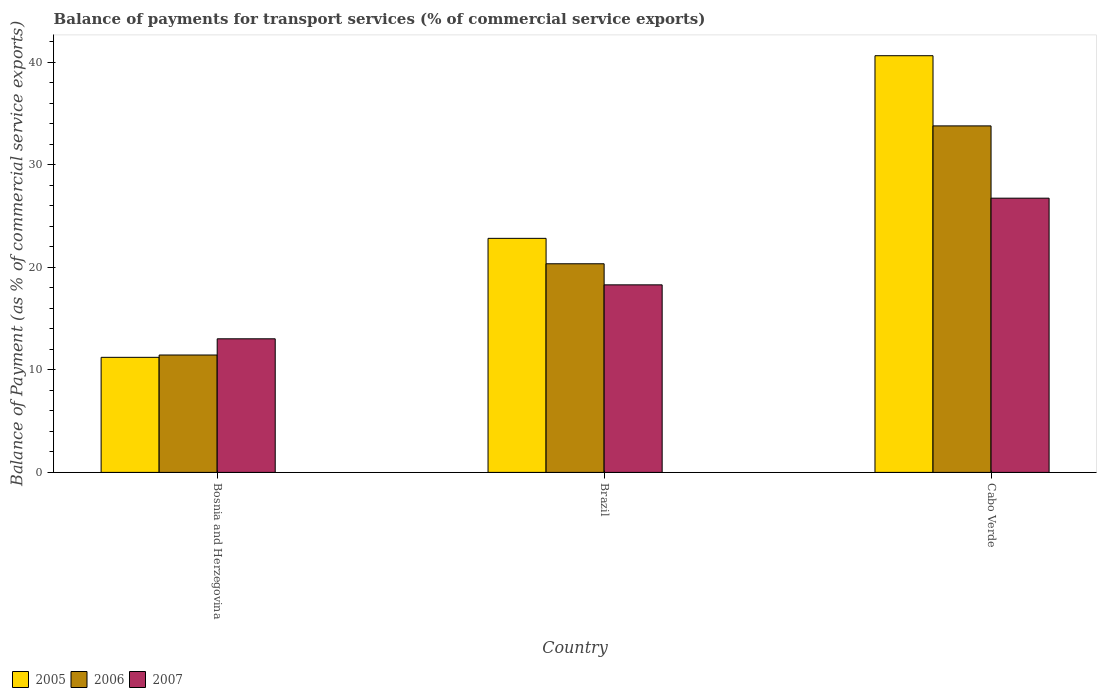How many different coloured bars are there?
Your answer should be compact. 3. Are the number of bars on each tick of the X-axis equal?
Provide a succinct answer. Yes. How many bars are there on the 1st tick from the left?
Provide a succinct answer. 3. How many bars are there on the 3rd tick from the right?
Make the answer very short. 3. What is the label of the 3rd group of bars from the left?
Make the answer very short. Cabo Verde. What is the balance of payments for transport services in 2007 in Cabo Verde?
Your answer should be very brief. 26.75. Across all countries, what is the maximum balance of payments for transport services in 2007?
Provide a succinct answer. 26.75. Across all countries, what is the minimum balance of payments for transport services in 2006?
Make the answer very short. 11.45. In which country was the balance of payments for transport services in 2006 maximum?
Provide a succinct answer. Cabo Verde. In which country was the balance of payments for transport services in 2005 minimum?
Provide a short and direct response. Bosnia and Herzegovina. What is the total balance of payments for transport services in 2005 in the graph?
Offer a very short reply. 74.69. What is the difference between the balance of payments for transport services in 2005 in Brazil and that in Cabo Verde?
Your answer should be compact. -17.81. What is the difference between the balance of payments for transport services in 2005 in Cabo Verde and the balance of payments for transport services in 2006 in Brazil?
Provide a succinct answer. 20.29. What is the average balance of payments for transport services in 2005 per country?
Give a very brief answer. 24.9. What is the difference between the balance of payments for transport services of/in 2006 and balance of payments for transport services of/in 2005 in Bosnia and Herzegovina?
Keep it short and to the point. 0.23. What is the ratio of the balance of payments for transport services in 2006 in Bosnia and Herzegovina to that in Cabo Verde?
Give a very brief answer. 0.34. Is the balance of payments for transport services in 2005 in Bosnia and Herzegovina less than that in Cabo Verde?
Your answer should be compact. Yes. Is the difference between the balance of payments for transport services in 2006 in Bosnia and Herzegovina and Cabo Verde greater than the difference between the balance of payments for transport services in 2005 in Bosnia and Herzegovina and Cabo Verde?
Offer a very short reply. Yes. What is the difference between the highest and the second highest balance of payments for transport services in 2005?
Your response must be concise. 29.42. What is the difference between the highest and the lowest balance of payments for transport services in 2005?
Provide a succinct answer. 29.42. In how many countries, is the balance of payments for transport services in 2007 greater than the average balance of payments for transport services in 2007 taken over all countries?
Provide a short and direct response. 1. Is the sum of the balance of payments for transport services in 2007 in Bosnia and Herzegovina and Brazil greater than the maximum balance of payments for transport services in 2005 across all countries?
Keep it short and to the point. No. What does the 1st bar from the left in Brazil represents?
Offer a very short reply. 2005. What does the 3rd bar from the right in Cabo Verde represents?
Ensure brevity in your answer.  2005. Is it the case that in every country, the sum of the balance of payments for transport services in 2006 and balance of payments for transport services in 2005 is greater than the balance of payments for transport services in 2007?
Offer a terse response. Yes. How many bars are there?
Your answer should be compact. 9. Are all the bars in the graph horizontal?
Provide a short and direct response. No. What is the difference between two consecutive major ticks on the Y-axis?
Make the answer very short. 10. Does the graph contain any zero values?
Your answer should be compact. No. How are the legend labels stacked?
Keep it short and to the point. Horizontal. What is the title of the graph?
Offer a very short reply. Balance of payments for transport services (% of commercial service exports). What is the label or title of the Y-axis?
Provide a short and direct response. Balance of Payment (as % of commercial service exports). What is the Balance of Payment (as % of commercial service exports) of 2005 in Bosnia and Herzegovina?
Offer a terse response. 11.22. What is the Balance of Payment (as % of commercial service exports) in 2006 in Bosnia and Herzegovina?
Ensure brevity in your answer.  11.45. What is the Balance of Payment (as % of commercial service exports) in 2007 in Bosnia and Herzegovina?
Keep it short and to the point. 13.03. What is the Balance of Payment (as % of commercial service exports) in 2005 in Brazil?
Provide a succinct answer. 22.83. What is the Balance of Payment (as % of commercial service exports) of 2006 in Brazil?
Offer a terse response. 20.35. What is the Balance of Payment (as % of commercial service exports) of 2007 in Brazil?
Your answer should be compact. 18.29. What is the Balance of Payment (as % of commercial service exports) in 2005 in Cabo Verde?
Provide a succinct answer. 40.64. What is the Balance of Payment (as % of commercial service exports) of 2006 in Cabo Verde?
Your answer should be compact. 33.79. What is the Balance of Payment (as % of commercial service exports) in 2007 in Cabo Verde?
Your answer should be compact. 26.75. Across all countries, what is the maximum Balance of Payment (as % of commercial service exports) in 2005?
Ensure brevity in your answer.  40.64. Across all countries, what is the maximum Balance of Payment (as % of commercial service exports) of 2006?
Provide a short and direct response. 33.79. Across all countries, what is the maximum Balance of Payment (as % of commercial service exports) in 2007?
Give a very brief answer. 26.75. Across all countries, what is the minimum Balance of Payment (as % of commercial service exports) in 2005?
Your response must be concise. 11.22. Across all countries, what is the minimum Balance of Payment (as % of commercial service exports) in 2006?
Provide a succinct answer. 11.45. Across all countries, what is the minimum Balance of Payment (as % of commercial service exports) of 2007?
Ensure brevity in your answer.  13.03. What is the total Balance of Payment (as % of commercial service exports) in 2005 in the graph?
Your answer should be compact. 74.69. What is the total Balance of Payment (as % of commercial service exports) in 2006 in the graph?
Your answer should be very brief. 65.59. What is the total Balance of Payment (as % of commercial service exports) of 2007 in the graph?
Offer a very short reply. 58.07. What is the difference between the Balance of Payment (as % of commercial service exports) in 2005 in Bosnia and Herzegovina and that in Brazil?
Your answer should be compact. -11.6. What is the difference between the Balance of Payment (as % of commercial service exports) of 2006 in Bosnia and Herzegovina and that in Brazil?
Give a very brief answer. -8.9. What is the difference between the Balance of Payment (as % of commercial service exports) in 2007 in Bosnia and Herzegovina and that in Brazil?
Your response must be concise. -5.26. What is the difference between the Balance of Payment (as % of commercial service exports) of 2005 in Bosnia and Herzegovina and that in Cabo Verde?
Your answer should be very brief. -29.42. What is the difference between the Balance of Payment (as % of commercial service exports) of 2006 in Bosnia and Herzegovina and that in Cabo Verde?
Make the answer very short. -22.35. What is the difference between the Balance of Payment (as % of commercial service exports) in 2007 in Bosnia and Herzegovina and that in Cabo Verde?
Ensure brevity in your answer.  -13.72. What is the difference between the Balance of Payment (as % of commercial service exports) of 2005 in Brazil and that in Cabo Verde?
Provide a short and direct response. -17.81. What is the difference between the Balance of Payment (as % of commercial service exports) of 2006 in Brazil and that in Cabo Verde?
Provide a short and direct response. -13.45. What is the difference between the Balance of Payment (as % of commercial service exports) in 2007 in Brazil and that in Cabo Verde?
Ensure brevity in your answer.  -8.45. What is the difference between the Balance of Payment (as % of commercial service exports) of 2005 in Bosnia and Herzegovina and the Balance of Payment (as % of commercial service exports) of 2006 in Brazil?
Make the answer very short. -9.13. What is the difference between the Balance of Payment (as % of commercial service exports) in 2005 in Bosnia and Herzegovina and the Balance of Payment (as % of commercial service exports) in 2007 in Brazil?
Keep it short and to the point. -7.07. What is the difference between the Balance of Payment (as % of commercial service exports) of 2006 in Bosnia and Herzegovina and the Balance of Payment (as % of commercial service exports) of 2007 in Brazil?
Keep it short and to the point. -6.84. What is the difference between the Balance of Payment (as % of commercial service exports) of 2005 in Bosnia and Herzegovina and the Balance of Payment (as % of commercial service exports) of 2006 in Cabo Verde?
Your answer should be very brief. -22.57. What is the difference between the Balance of Payment (as % of commercial service exports) of 2005 in Bosnia and Herzegovina and the Balance of Payment (as % of commercial service exports) of 2007 in Cabo Verde?
Your answer should be very brief. -15.52. What is the difference between the Balance of Payment (as % of commercial service exports) in 2006 in Bosnia and Herzegovina and the Balance of Payment (as % of commercial service exports) in 2007 in Cabo Verde?
Offer a terse response. -15.3. What is the difference between the Balance of Payment (as % of commercial service exports) of 2005 in Brazil and the Balance of Payment (as % of commercial service exports) of 2006 in Cabo Verde?
Your response must be concise. -10.97. What is the difference between the Balance of Payment (as % of commercial service exports) of 2005 in Brazil and the Balance of Payment (as % of commercial service exports) of 2007 in Cabo Verde?
Make the answer very short. -3.92. What is the difference between the Balance of Payment (as % of commercial service exports) in 2006 in Brazil and the Balance of Payment (as % of commercial service exports) in 2007 in Cabo Verde?
Your answer should be compact. -6.4. What is the average Balance of Payment (as % of commercial service exports) in 2005 per country?
Make the answer very short. 24.9. What is the average Balance of Payment (as % of commercial service exports) of 2006 per country?
Your answer should be very brief. 21.86. What is the average Balance of Payment (as % of commercial service exports) of 2007 per country?
Ensure brevity in your answer.  19.36. What is the difference between the Balance of Payment (as % of commercial service exports) of 2005 and Balance of Payment (as % of commercial service exports) of 2006 in Bosnia and Herzegovina?
Ensure brevity in your answer.  -0.23. What is the difference between the Balance of Payment (as % of commercial service exports) in 2005 and Balance of Payment (as % of commercial service exports) in 2007 in Bosnia and Herzegovina?
Offer a terse response. -1.81. What is the difference between the Balance of Payment (as % of commercial service exports) of 2006 and Balance of Payment (as % of commercial service exports) of 2007 in Bosnia and Herzegovina?
Your answer should be very brief. -1.58. What is the difference between the Balance of Payment (as % of commercial service exports) in 2005 and Balance of Payment (as % of commercial service exports) in 2006 in Brazil?
Provide a succinct answer. 2.48. What is the difference between the Balance of Payment (as % of commercial service exports) in 2005 and Balance of Payment (as % of commercial service exports) in 2007 in Brazil?
Give a very brief answer. 4.54. What is the difference between the Balance of Payment (as % of commercial service exports) of 2006 and Balance of Payment (as % of commercial service exports) of 2007 in Brazil?
Your answer should be very brief. 2.06. What is the difference between the Balance of Payment (as % of commercial service exports) of 2005 and Balance of Payment (as % of commercial service exports) of 2006 in Cabo Verde?
Your response must be concise. 6.85. What is the difference between the Balance of Payment (as % of commercial service exports) of 2005 and Balance of Payment (as % of commercial service exports) of 2007 in Cabo Verde?
Make the answer very short. 13.89. What is the difference between the Balance of Payment (as % of commercial service exports) in 2006 and Balance of Payment (as % of commercial service exports) in 2007 in Cabo Verde?
Give a very brief answer. 7.05. What is the ratio of the Balance of Payment (as % of commercial service exports) in 2005 in Bosnia and Herzegovina to that in Brazil?
Keep it short and to the point. 0.49. What is the ratio of the Balance of Payment (as % of commercial service exports) in 2006 in Bosnia and Herzegovina to that in Brazil?
Keep it short and to the point. 0.56. What is the ratio of the Balance of Payment (as % of commercial service exports) in 2007 in Bosnia and Herzegovina to that in Brazil?
Give a very brief answer. 0.71. What is the ratio of the Balance of Payment (as % of commercial service exports) of 2005 in Bosnia and Herzegovina to that in Cabo Verde?
Offer a terse response. 0.28. What is the ratio of the Balance of Payment (as % of commercial service exports) in 2006 in Bosnia and Herzegovina to that in Cabo Verde?
Your response must be concise. 0.34. What is the ratio of the Balance of Payment (as % of commercial service exports) in 2007 in Bosnia and Herzegovina to that in Cabo Verde?
Make the answer very short. 0.49. What is the ratio of the Balance of Payment (as % of commercial service exports) in 2005 in Brazil to that in Cabo Verde?
Provide a succinct answer. 0.56. What is the ratio of the Balance of Payment (as % of commercial service exports) of 2006 in Brazil to that in Cabo Verde?
Provide a succinct answer. 0.6. What is the ratio of the Balance of Payment (as % of commercial service exports) in 2007 in Brazil to that in Cabo Verde?
Offer a very short reply. 0.68. What is the difference between the highest and the second highest Balance of Payment (as % of commercial service exports) of 2005?
Your answer should be compact. 17.81. What is the difference between the highest and the second highest Balance of Payment (as % of commercial service exports) in 2006?
Give a very brief answer. 13.45. What is the difference between the highest and the second highest Balance of Payment (as % of commercial service exports) of 2007?
Give a very brief answer. 8.45. What is the difference between the highest and the lowest Balance of Payment (as % of commercial service exports) in 2005?
Your answer should be compact. 29.42. What is the difference between the highest and the lowest Balance of Payment (as % of commercial service exports) in 2006?
Make the answer very short. 22.35. What is the difference between the highest and the lowest Balance of Payment (as % of commercial service exports) in 2007?
Offer a very short reply. 13.72. 